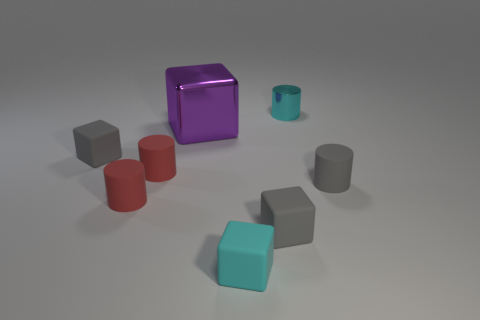What is the shape of the purple object that is made of the same material as the cyan cylinder?
Ensure brevity in your answer.  Cube. How many other objects are there of the same shape as the big purple shiny object?
Keep it short and to the point. 3. Is the size of the matte cube behind the gray cylinder the same as the big purple metallic object?
Keep it short and to the point. No. Are there more small gray rubber cubes on the right side of the purple block than cyan rubber cylinders?
Your answer should be compact. Yes. There is a cylinder that is right of the small cyan shiny cylinder; how many rubber cylinders are behind it?
Keep it short and to the point. 1. Is the number of gray objects left of the tiny gray matte cylinder less than the number of tiny matte blocks?
Give a very brief answer. Yes. Is there a tiny metal object in front of the matte thing on the right side of the tiny cyan thing behind the large metallic thing?
Give a very brief answer. No. Is the cyan cylinder made of the same material as the large purple thing in front of the tiny shiny cylinder?
Your answer should be very brief. Yes. What is the color of the metal thing left of the tiny gray block that is on the right side of the big block?
Offer a very short reply. Purple. Are there any objects of the same color as the large shiny block?
Keep it short and to the point. No. 